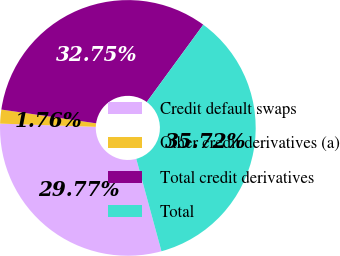<chart> <loc_0><loc_0><loc_500><loc_500><pie_chart><fcel>Credit default swaps<fcel>Other credit derivatives (a)<fcel>Total credit derivatives<fcel>Total<nl><fcel>29.77%<fcel>1.76%<fcel>32.75%<fcel>35.72%<nl></chart> 